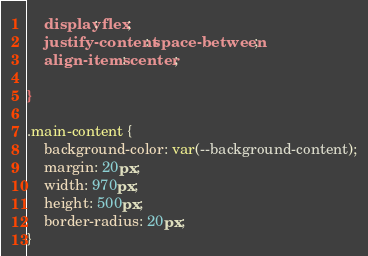Convert code to text. <code><loc_0><loc_0><loc_500><loc_500><_CSS_>
    display: flex;
    justify-content: space-between;
    align-items: center;
    
}

.main-content {
    background-color: var(--background-content);
    margin: 20px;
    width: 970px;
    height: 500px;
    border-radius: 20px;
}</code> 